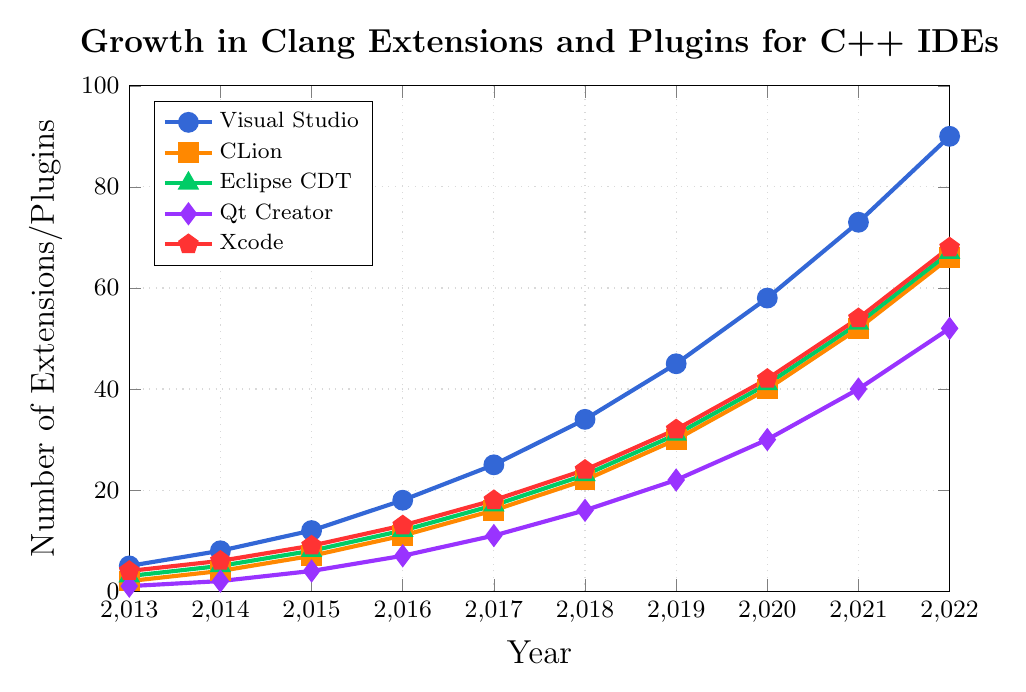What's the trend of the number of Visual Studio extensions from 2013 to 2022? The number of Visual Studio extensions increases continuously over the years. In 2013, it starts at 5 and each subsequent year it grows, reaching 90 in 2022.
Answer: It increases How many Qt Creator extensions were developed between 2018 and 2022? To find the total number of Qt Creator extensions from 2018 to 2022, sum the values for each year: 16 (2018) + 22 (2019) + 30 (2020) + 40 (2021) + 52 (2022).
Answer: 160 Which IDE had the highest number of extensions developed in 2019? Looking at the data points for the year 2019, Visual Studio has the highest value with 45 extensions.
Answer: Visual Studio In which year did Eclipse CDT surpass 50 extensions? Checking the values for Eclipse CDT, it surpasses 50 extensions in 2021, where the value is 53.
Answer: 2021 How does the growth in extensions/plugins for CLion compare to Xcode over the period shown? To compare the growth, note the difference in the number of extensions/plugins for both IDEs over the years. CLion starts at 2 in 2013 and reaches 66 in 2022, while Xcode starts at 4 and reaches 68 in the same period. Both IDEs show a similar growth trend but Xcode consistently has slightly more extensions.
Answer: Similar growth, Xcode slightly higher What is the average number of Eclipse CDT extensions between 2013 and 2022? Sum the number of Eclipse CDT extensions from 2013 to 2022 and divide by the number of years: (3+5+8+12+17+23+31+41+53+67) / 10.
Answer: 26 How many more extensions did Visual Studio have compared to Qt Creator in 2021? Subtract the number of Qt Creator extensions from Visual Studio extensions in 2021: 73 - 40.
Answer: 33 Which IDE showed the most significant increase in extensions from 2013 to 2014? By calculating the yearly increase for each IDE from 2013 to 2014, Visual Studio shows the highest increase: 8 - 5 = 3, CLion: 4 - 2 = 2, Eclipse CDT: 5 - 3 = 2, Qt Creator: 2 - 1 = 1, Xcode: 6 - 4 = 2.
Answer: Visual Studio Which IDE had the slowest growth in the number of extensions/plugins in 2016? By comparing the increase in the number of extensions/plugins from 2015 to 2016, Qt Creator shows the smallest increase: 7 - 4 = 3. Here are the increases for the others: Visual Studio: 6, CLion: 4, Eclipse CDT: 4, and Xcode: 4.
Answer: Qt Creator How does the number of CLion extensions in 2017 compare to the number of Qt Creator extensions in 2022? Compare the 16 CLion extensions in 2017 to the 52 Qt Creator extensions in 2022.
Answer: Qt Creator has more 